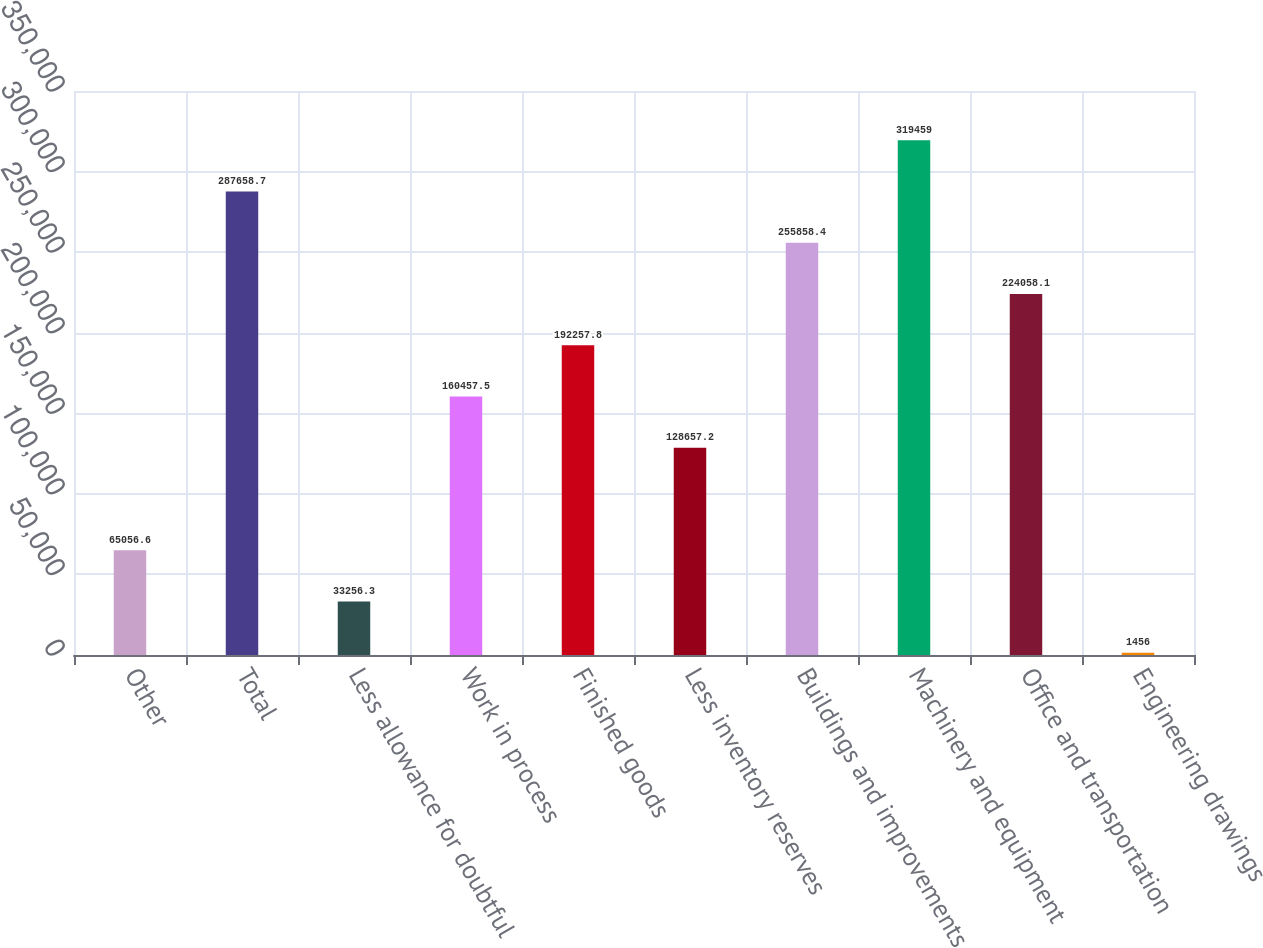Convert chart. <chart><loc_0><loc_0><loc_500><loc_500><bar_chart><fcel>Other<fcel>Total<fcel>Less allowance for doubtful<fcel>Work in process<fcel>Finished goods<fcel>Less inventory reserves<fcel>Buildings and improvements<fcel>Machinery and equipment<fcel>Office and transportation<fcel>Engineering drawings<nl><fcel>65056.6<fcel>287659<fcel>33256.3<fcel>160458<fcel>192258<fcel>128657<fcel>255858<fcel>319459<fcel>224058<fcel>1456<nl></chart> 